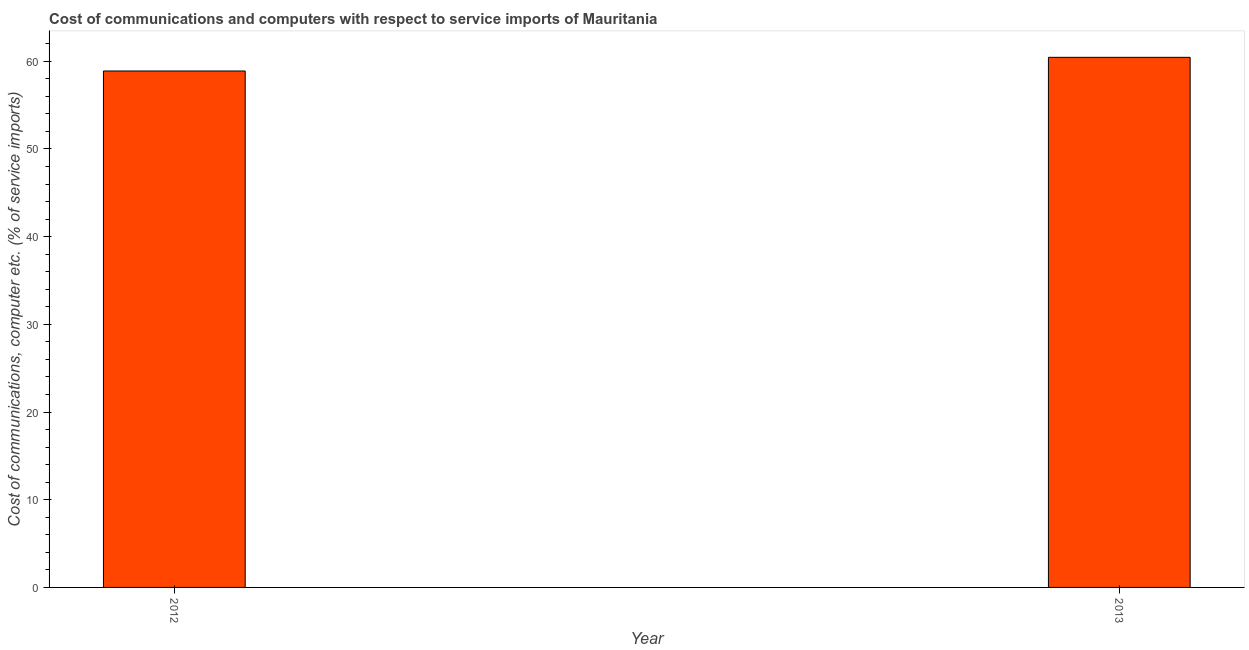Does the graph contain any zero values?
Provide a succinct answer. No. Does the graph contain grids?
Your answer should be compact. No. What is the title of the graph?
Your answer should be compact. Cost of communications and computers with respect to service imports of Mauritania. What is the label or title of the Y-axis?
Make the answer very short. Cost of communications, computer etc. (% of service imports). What is the cost of communications and computer in 2013?
Your answer should be very brief. 60.45. Across all years, what is the maximum cost of communications and computer?
Provide a short and direct response. 60.45. Across all years, what is the minimum cost of communications and computer?
Your response must be concise. 58.89. In which year was the cost of communications and computer maximum?
Your response must be concise. 2013. What is the sum of the cost of communications and computer?
Give a very brief answer. 119.34. What is the difference between the cost of communications and computer in 2012 and 2013?
Provide a short and direct response. -1.56. What is the average cost of communications and computer per year?
Make the answer very short. 59.67. What is the median cost of communications and computer?
Provide a succinct answer. 59.67. Is the cost of communications and computer in 2012 less than that in 2013?
Keep it short and to the point. Yes. Are all the bars in the graph horizontal?
Offer a terse response. No. How many years are there in the graph?
Your response must be concise. 2. Are the values on the major ticks of Y-axis written in scientific E-notation?
Your response must be concise. No. What is the Cost of communications, computer etc. (% of service imports) of 2012?
Your response must be concise. 58.89. What is the Cost of communications, computer etc. (% of service imports) in 2013?
Keep it short and to the point. 60.45. What is the difference between the Cost of communications, computer etc. (% of service imports) in 2012 and 2013?
Offer a very short reply. -1.56. What is the ratio of the Cost of communications, computer etc. (% of service imports) in 2012 to that in 2013?
Provide a succinct answer. 0.97. 